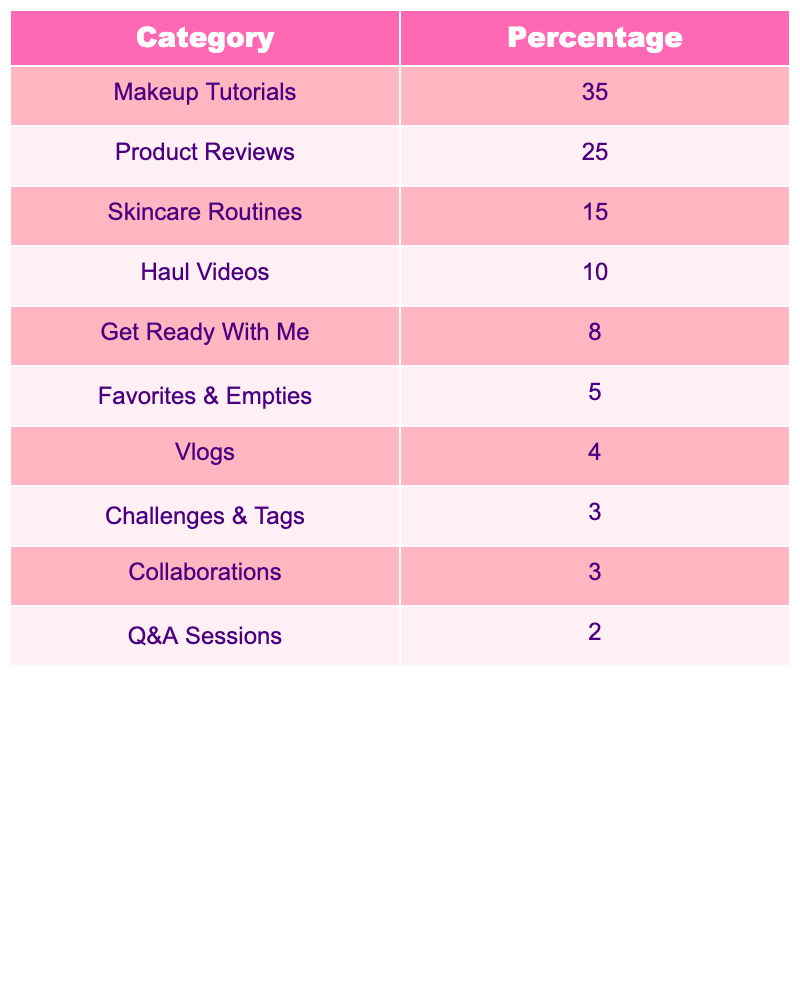What percentage of content is dedicated to makeup tutorials? The table shows that makeup tutorials make up 35% of the video categories for successful beauty YouTubers in their first year.
Answer: 35% What is the percentage difference between product reviews and skincare routines? Product reviews account for 25%, while skincare routines account for 15%. The difference is 25% - 15% = 10%.
Answer: 10% Are haul videos one of the top three most popular categories? The top three categories are makeup tutorials (35%), product reviews (25%), and skincare routines (15%). Haul videos are in fourth place with 10%, so they are not in the top three.
Answer: No What is the combined percentage of vlogs, challenges & tags, and collaborations? Vlogs are at 4%, challenges & tags are at 3%, and collaborations are also at 3%. The combined percentage is 4% + 3% + 3% = 10%.
Answer: 10% Which category has the least percentage, and what is that percentage? The category with the least percentage is Q&A sessions at 2%.
Answer: 2% If a beauty YouTuber creates 100 videos, how many videos would you expect to be product reviews and makeup tutorials combined? The percentage for product reviews is 25% and for makeup tutorials is 35%. Combined, they total 25% + 35% = 60%. If they create 100 videos, then 60% of 100 is 60 videos dedicated to these categories.
Answer: 60 videos Which category has a higher percentage: 'Get Ready With Me' or 'Favorites & Empties'? 'Get Ready With Me' has a percentage of 8%, while 'Favorites & Empties' has 5%. Since 8% is greater than 5%, 'Get Ready With Me' is higher.
Answer: Get Ready With Me What is the average percentage of all video categories listed? To find the average, add up all the percentages: 35 + 25 + 15 + 10 + 8 + 5 + 4 + 3 + 3 + 2 = 104. Then divide by the number of categories (10): 104/10 = 10.4%.
Answer: 10.4% If a YouTuber decides to only focus on makeup tutorials and product reviews in their first year, what percentage of their videos would that represent? Makeup tutorials are 35%, and product reviews are 25%. Together, they make 35% + 25% = 60% of the total content.
Answer: 60% Which category would you say is significantly less popular compared to makeup tutorials? Makeup tutorials have a high percentage at 35%, while the lowest category, Q&A sessions, only has 2%. This indicates that Q&A sessions are significantly less popular than makeup tutorials.
Answer: Q&A sessions 